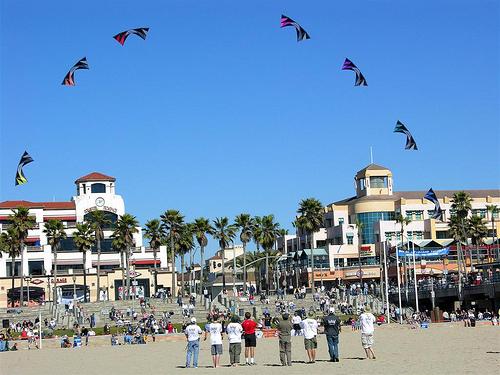How many people are wearing shorts in the forefront of this photo?
Give a very brief answer. 4. Is this an indoor or outdoor photo?
Write a very short answer. Outdoor. Are those kites in the air?
Give a very brief answer. Yes. 